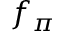Convert formula to latex. <formula><loc_0><loc_0><loc_500><loc_500>f _ { \pi }</formula> 